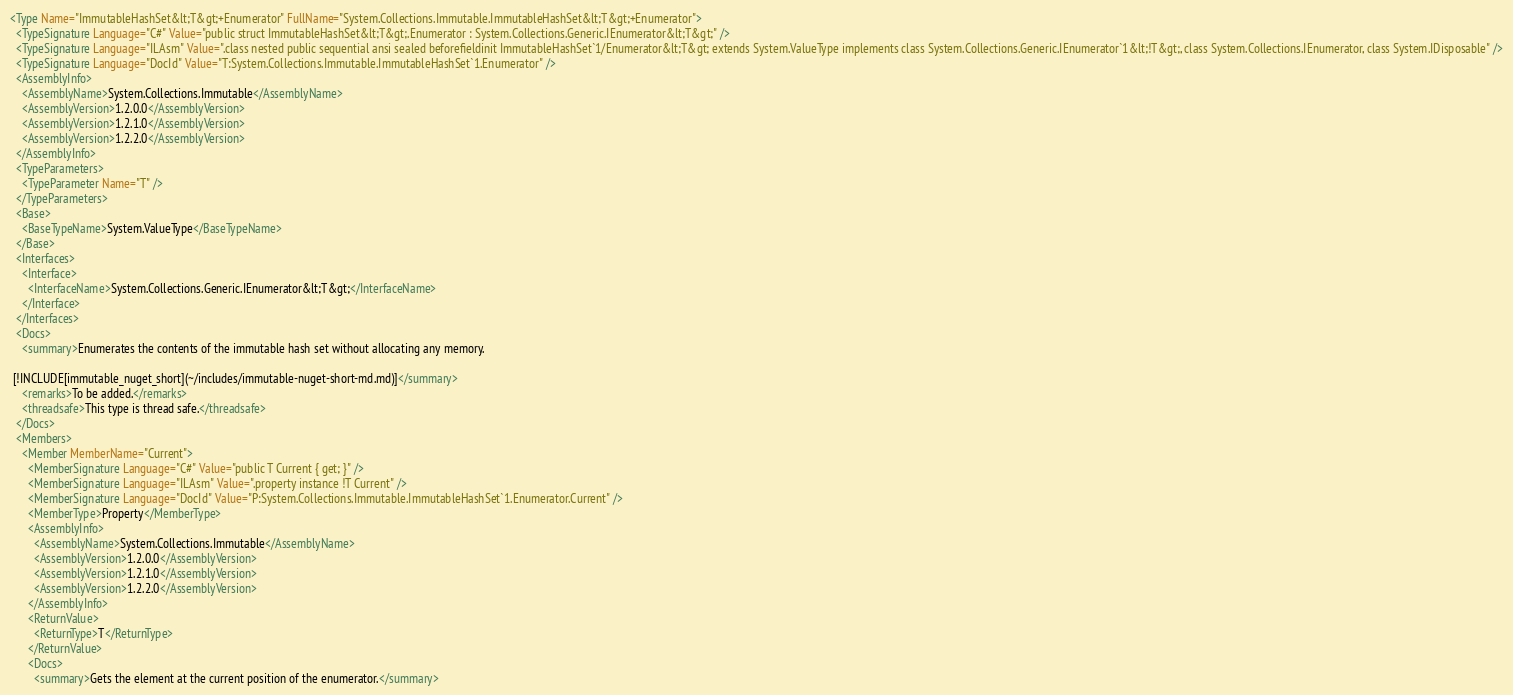<code> <loc_0><loc_0><loc_500><loc_500><_XML_><Type Name="ImmutableHashSet&lt;T&gt;+Enumerator" FullName="System.Collections.Immutable.ImmutableHashSet&lt;T&gt;+Enumerator">
  <TypeSignature Language="C#" Value="public struct ImmutableHashSet&lt;T&gt;.Enumerator : System.Collections.Generic.IEnumerator&lt;T&gt;" />
  <TypeSignature Language="ILAsm" Value=".class nested public sequential ansi sealed beforefieldinit ImmutableHashSet`1/Enumerator&lt;T&gt; extends System.ValueType implements class System.Collections.Generic.IEnumerator`1&lt;!T&gt;, class System.Collections.IEnumerator, class System.IDisposable" />
  <TypeSignature Language="DocId" Value="T:System.Collections.Immutable.ImmutableHashSet`1.Enumerator" />
  <AssemblyInfo>
    <AssemblyName>System.Collections.Immutable</AssemblyName>
    <AssemblyVersion>1.2.0.0</AssemblyVersion>
    <AssemblyVersion>1.2.1.0</AssemblyVersion>
    <AssemblyVersion>1.2.2.0</AssemblyVersion>
  </AssemblyInfo>
  <TypeParameters>
    <TypeParameter Name="T" />
  </TypeParameters>
  <Base>
    <BaseTypeName>System.ValueType</BaseTypeName>
  </Base>
  <Interfaces>
    <Interface>
      <InterfaceName>System.Collections.Generic.IEnumerator&lt;T&gt;</InterfaceName>
    </Interface>
  </Interfaces>
  <Docs>
    <summary>Enumerates the contents of the immutable hash set without allocating any memory.  
  
 [!INCLUDE[immutable_nuget_short](~/includes/immutable-nuget-short-md.md)]</summary>
    <remarks>To be added.</remarks>
    <threadsafe>This type is thread safe.</threadsafe>
  </Docs>
  <Members>
    <Member MemberName="Current">
      <MemberSignature Language="C#" Value="public T Current { get; }" />
      <MemberSignature Language="ILAsm" Value=".property instance !T Current" />
      <MemberSignature Language="DocId" Value="P:System.Collections.Immutable.ImmutableHashSet`1.Enumerator.Current" />
      <MemberType>Property</MemberType>
      <AssemblyInfo>
        <AssemblyName>System.Collections.Immutable</AssemblyName>
        <AssemblyVersion>1.2.0.0</AssemblyVersion>
        <AssemblyVersion>1.2.1.0</AssemblyVersion>
        <AssemblyVersion>1.2.2.0</AssemblyVersion>
      </AssemblyInfo>
      <ReturnValue>
        <ReturnType>T</ReturnType>
      </ReturnValue>
      <Docs>
        <summary>Gets the element at the current position of the enumerator.</summary></code> 